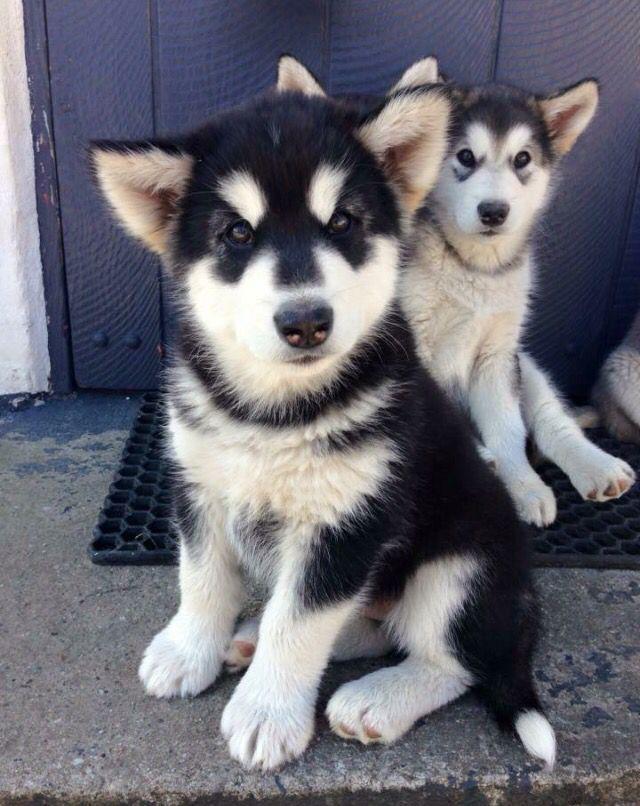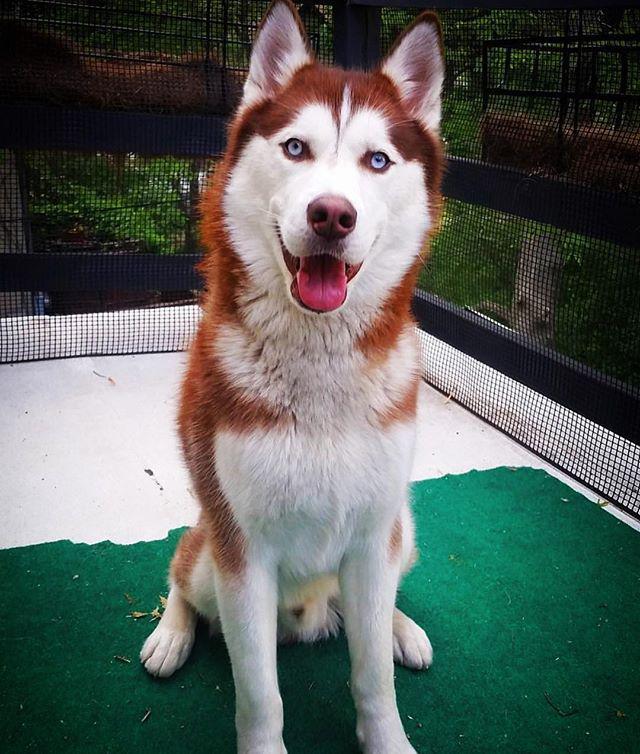The first image is the image on the left, the second image is the image on the right. Evaluate the accuracy of this statement regarding the images: "One of the dogs is brown and white.". Is it true? Answer yes or no. Yes. The first image is the image on the left, the second image is the image on the right. For the images displayed, is the sentence "Three or more mammals are visible." factually correct? Answer yes or no. Yes. 